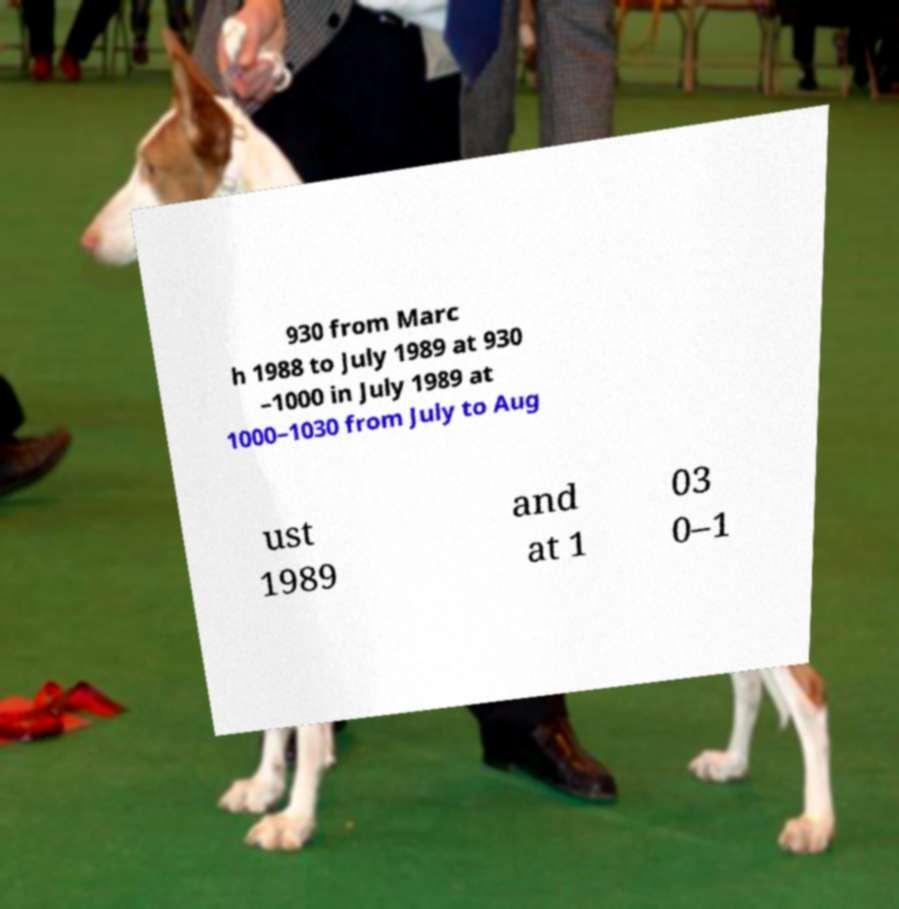I need the written content from this picture converted into text. Can you do that? 930 from Marc h 1988 to July 1989 at 930 –1000 in July 1989 at 1000–1030 from July to Aug ust 1989 and at 1 03 0–1 